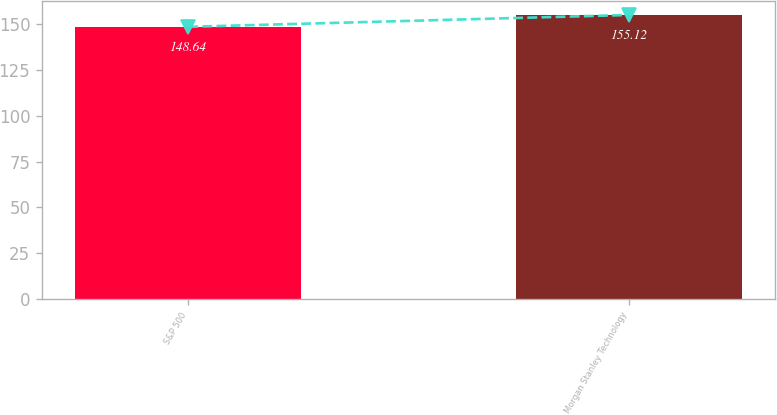Convert chart. <chart><loc_0><loc_0><loc_500><loc_500><bar_chart><fcel>S&P 500<fcel>Morgan Stanley Technology<nl><fcel>148.64<fcel>155.12<nl></chart> 